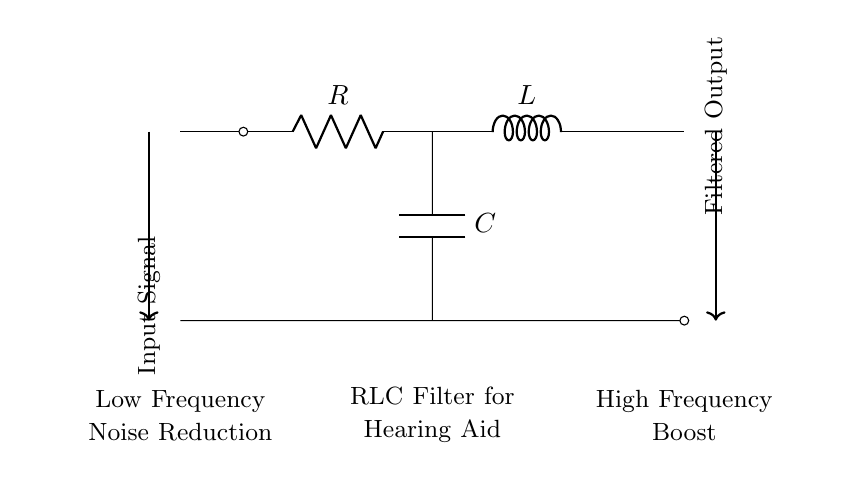What components are in the circuit? The circuit contains a resistor, inductor, and capacitor, which are essential elements of an RLC filter. Each component serves a specific function in filtering signals.
Answer: Resistor, inductor, capacitor What is the function of the resistor in this circuit? The resistor controls the current flow and dissipates energy as heat, playing a role in determining the filter's cut-off frequency alongside the inductor and capacitor.
Answer: Current control What type of filter is represented in this circuit? The arrangement of the resistor, inductor, and capacitor indicates that this circuit is a band-pass filter, allowing certain frequencies to pass while attenuating others.
Answer: Band-pass filter How does the inductor affect high-frequency signals? The inductor presents high impedance to high-frequency signals, thereby attenuating them, while allowing low-frequency signals to pass through the filter.
Answer: Attenuates high frequencies What is the purpose of the capacitor in this context? The capacitor provides a path for high-frequency signals to ground, thus filtering them out, while allowing low-frequency signals to remain in the output.
Answer: Filters high frequencies What is the expected output response for low-frequency signals? Low-frequency signals are expected to pass through the circuit with minimal attenuation, contributing to the enhanced sound quality in hearing aids.
Answer: Minimal attenuation What role does the combination of components play in hearing aids? The interaction of the resistor, inductor, and capacitor in this configuration helps in noise reduction and sound quality improvement by selectively filtering out unwanted frequencies.
Answer: Noise reduction and sound quality improvement 